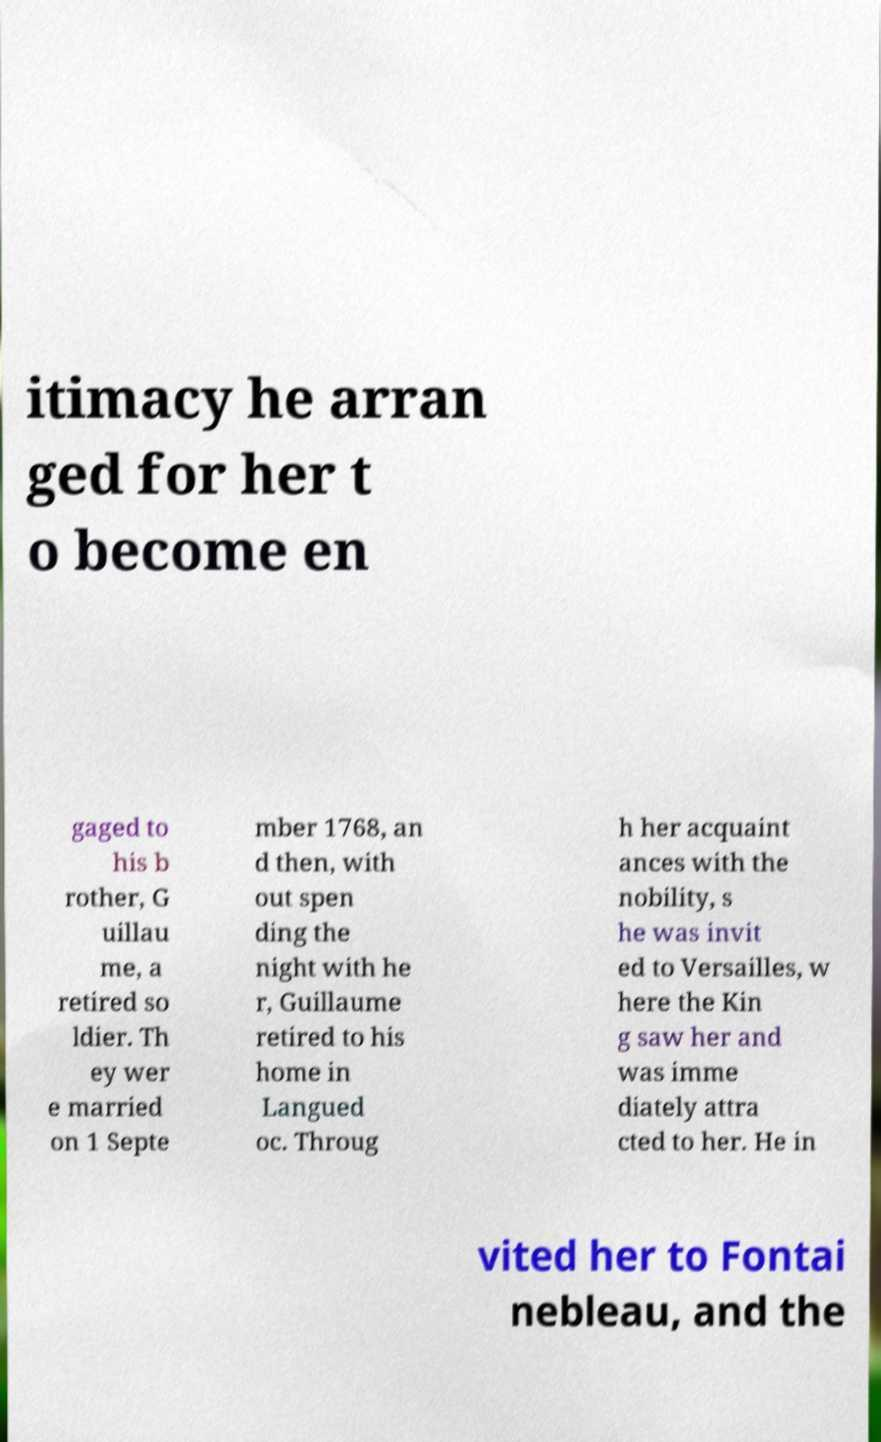Can you read and provide the text displayed in the image?This photo seems to have some interesting text. Can you extract and type it out for me? itimacy he arran ged for her t o become en gaged to his b rother, G uillau me, a retired so ldier. Th ey wer e married on 1 Septe mber 1768, an d then, with out spen ding the night with he r, Guillaume retired to his home in Langued oc. Throug h her acquaint ances with the nobility, s he was invit ed to Versailles, w here the Kin g saw her and was imme diately attra cted to her. He in vited her to Fontai nebleau, and the 